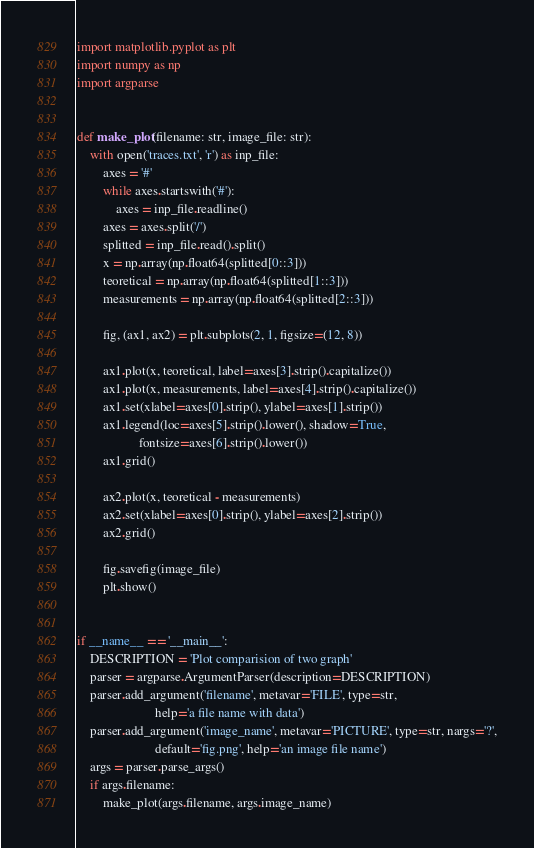<code> <loc_0><loc_0><loc_500><loc_500><_Python_>import matplotlib.pyplot as plt
import numpy as np
import argparse


def make_plot(filename: str, image_file: str):
    with open('traces.txt', 'r') as inp_file:
        axes = '#'
        while axes.startswith('#'):
            axes = inp_file.readline()
        axes = axes.split('/')
        splitted = inp_file.read().split()
        x = np.array(np.float64(splitted[0::3]))
        teoretical = np.array(np.float64(splitted[1::3]))
        measurements = np.array(np.float64(splitted[2::3]))

        fig, (ax1, ax2) = plt.subplots(2, 1, figsize=(12, 8))

        ax1.plot(x, teoretical, label=axes[3].strip().capitalize())
        ax1.plot(x, measurements, label=axes[4].strip().capitalize())
        ax1.set(xlabel=axes[0].strip(), ylabel=axes[1].strip())
        ax1.legend(loc=axes[5].strip().lower(), shadow=True,
                   fontsize=axes[6].strip().lower())
        ax1.grid()

        ax2.plot(x, teoretical - measurements)
        ax2.set(xlabel=axes[0].strip(), ylabel=axes[2].strip())
        ax2.grid()

        fig.savefig(image_file)
        plt.show()


if __name__ == '__main__':
    DESCRIPTION = 'Plot comparision of two graph'
    parser = argparse.ArgumentParser(description=DESCRIPTION)
    parser.add_argument('filename', metavar='FILE', type=str,
                        help='a file name with data')
    parser.add_argument('image_name', metavar='PICTURE', type=str, nargs='?',
                        default='fig.png', help='an image file name')
    args = parser.parse_args()
    if args.filename:
        make_plot(args.filename, args.image_name)
</code> 